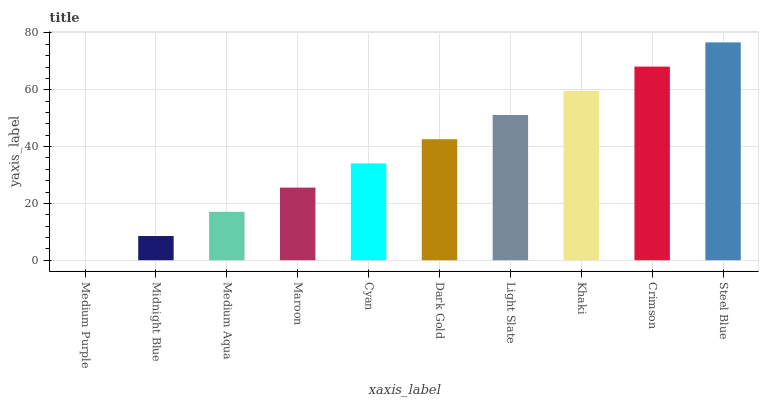Is Medium Purple the minimum?
Answer yes or no. Yes. Is Steel Blue the maximum?
Answer yes or no. Yes. Is Midnight Blue the minimum?
Answer yes or no. No. Is Midnight Blue the maximum?
Answer yes or no. No. Is Midnight Blue greater than Medium Purple?
Answer yes or no. Yes. Is Medium Purple less than Midnight Blue?
Answer yes or no. Yes. Is Medium Purple greater than Midnight Blue?
Answer yes or no. No. Is Midnight Blue less than Medium Purple?
Answer yes or no. No. Is Dark Gold the high median?
Answer yes or no. Yes. Is Cyan the low median?
Answer yes or no. Yes. Is Medium Aqua the high median?
Answer yes or no. No. Is Crimson the low median?
Answer yes or no. No. 